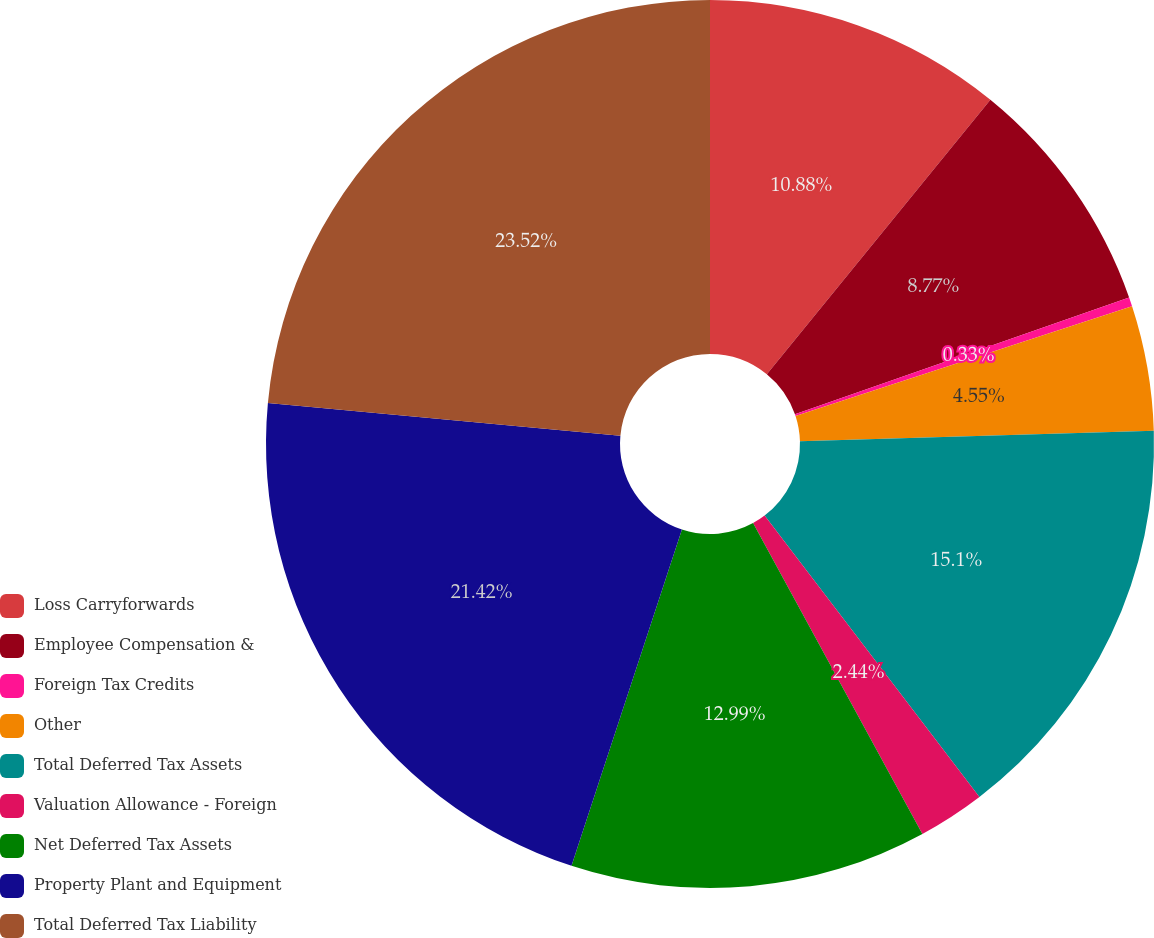Convert chart to OTSL. <chart><loc_0><loc_0><loc_500><loc_500><pie_chart><fcel>Loss Carryforwards<fcel>Employee Compensation &<fcel>Foreign Tax Credits<fcel>Other<fcel>Total Deferred Tax Assets<fcel>Valuation Allowance - Foreign<fcel>Net Deferred Tax Assets<fcel>Property Plant and Equipment<fcel>Total Deferred Tax Liability<nl><fcel>10.88%<fcel>8.77%<fcel>0.33%<fcel>4.55%<fcel>15.1%<fcel>2.44%<fcel>12.99%<fcel>21.43%<fcel>23.53%<nl></chart> 